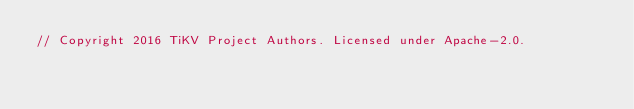<code> <loc_0><loc_0><loc_500><loc_500><_Rust_>// Copyright 2016 TiKV Project Authors. Licensed under Apache-2.0.
</code> 